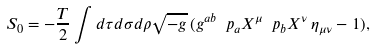Convert formula to latex. <formula><loc_0><loc_0><loc_500><loc_500>S _ { 0 } = - \frac { T } { 2 } \int d \tau d \sigma d \rho \sqrt { - g } \, ( g ^ { a b } \ p _ { a } X ^ { \mu } \ p _ { b } X ^ { \nu } \, \eta _ { \mu \nu } - 1 ) ,</formula> 